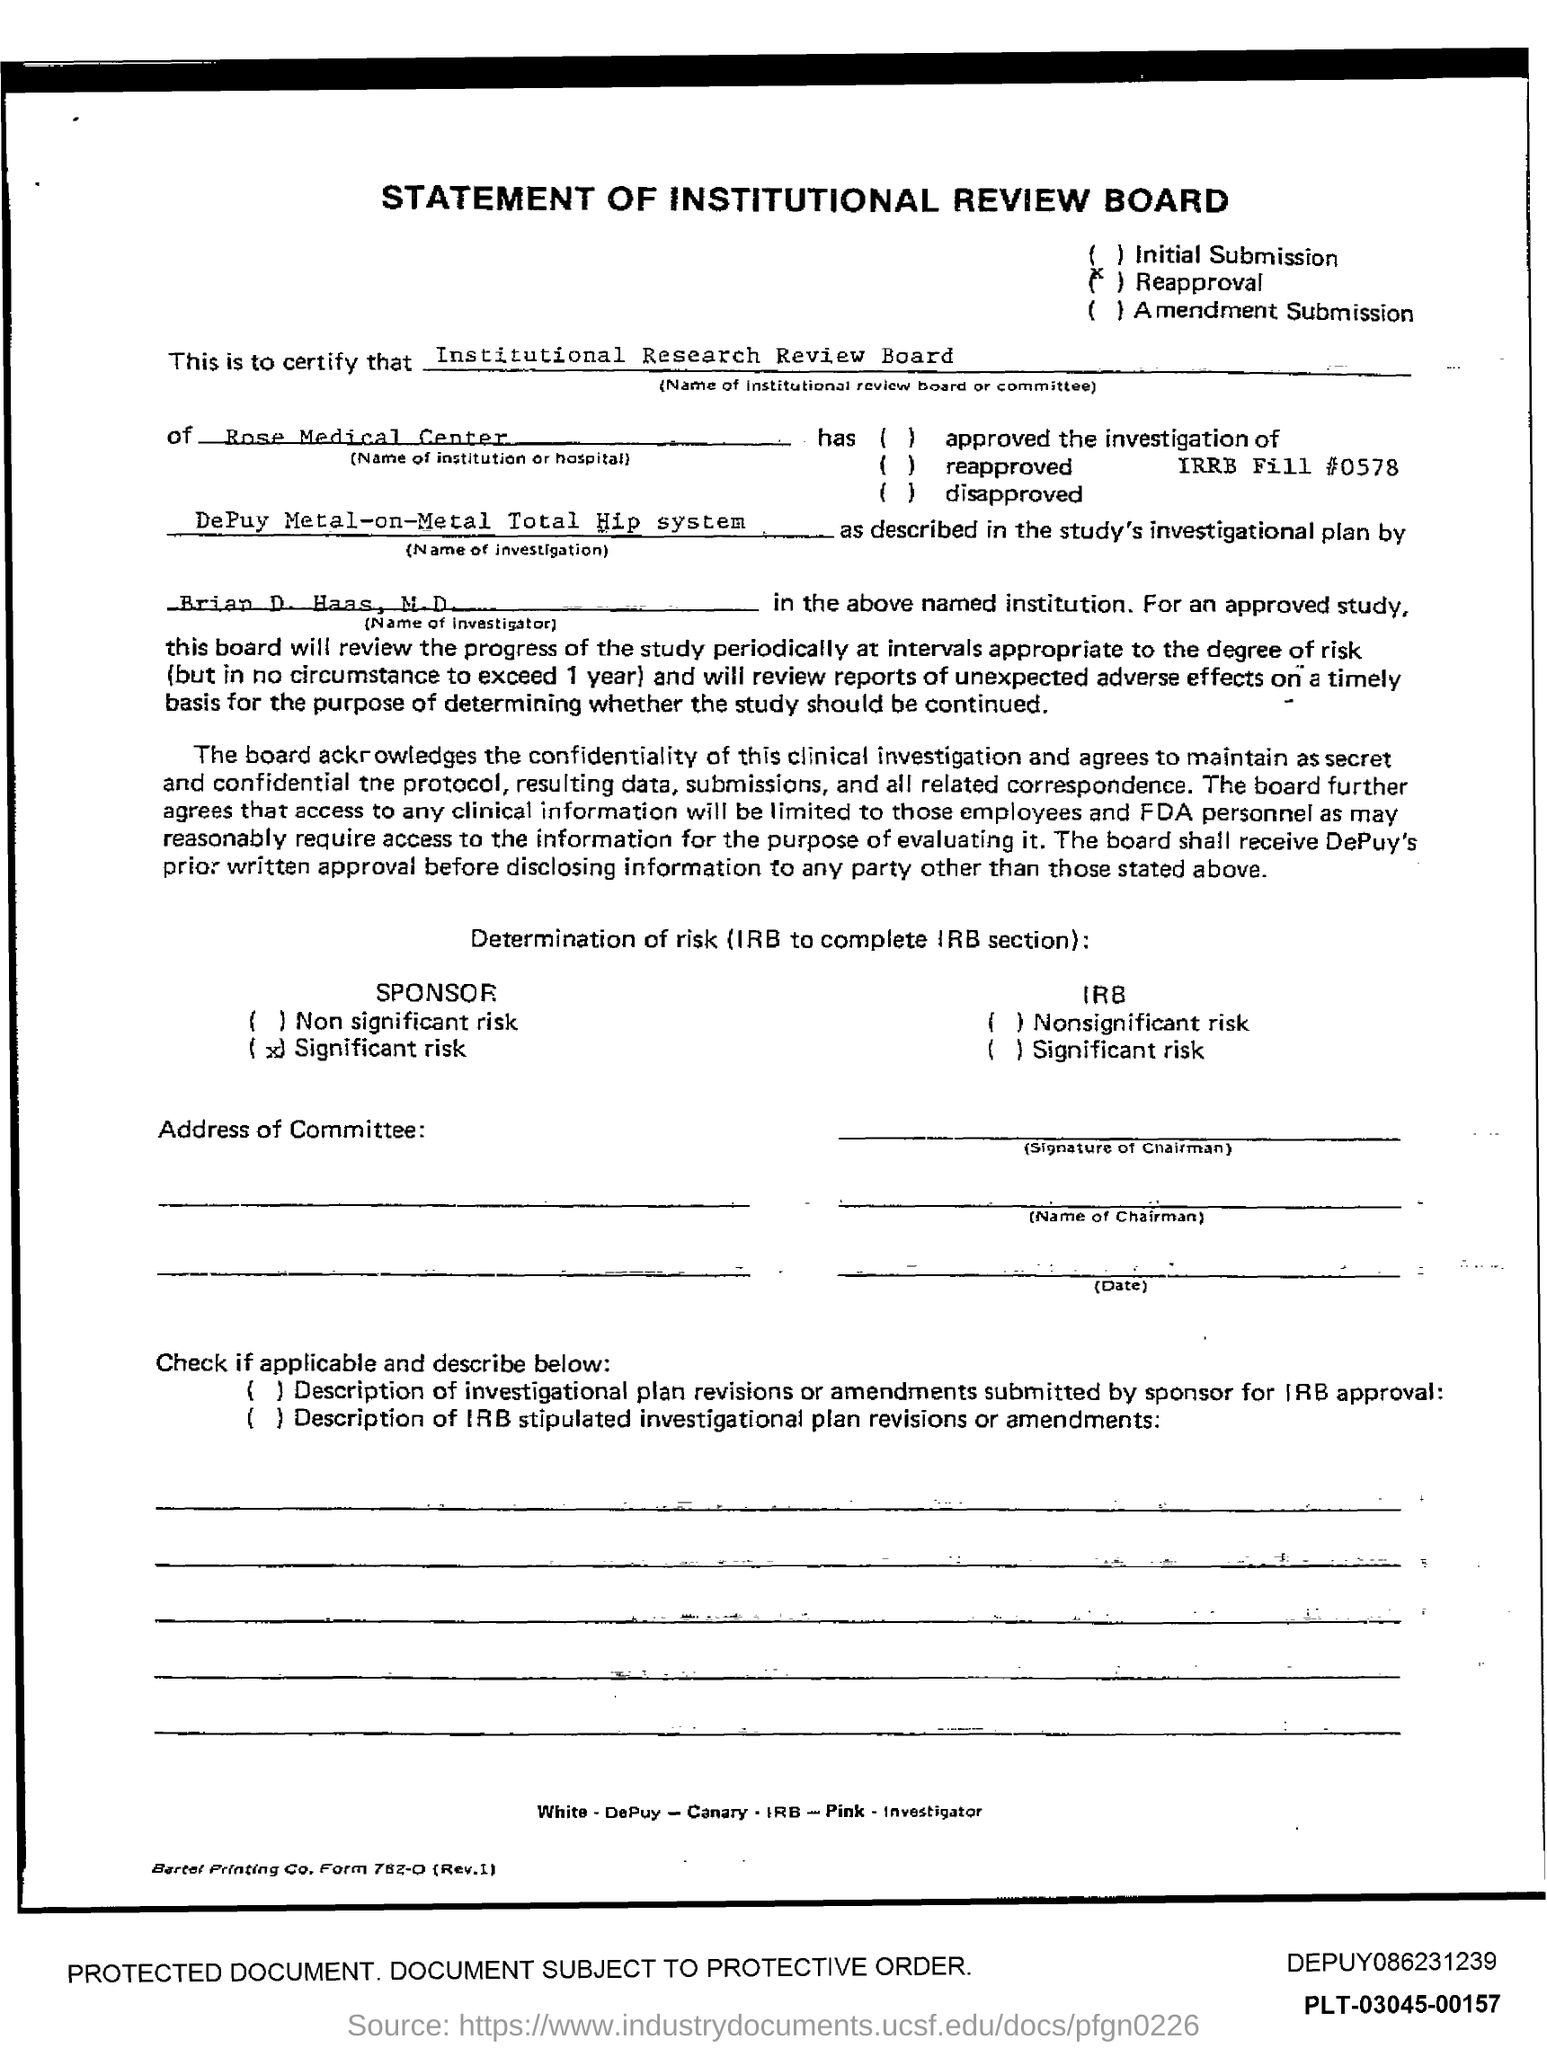What is the title of this statement?
Ensure brevity in your answer.  Statement of Institutional review board. 